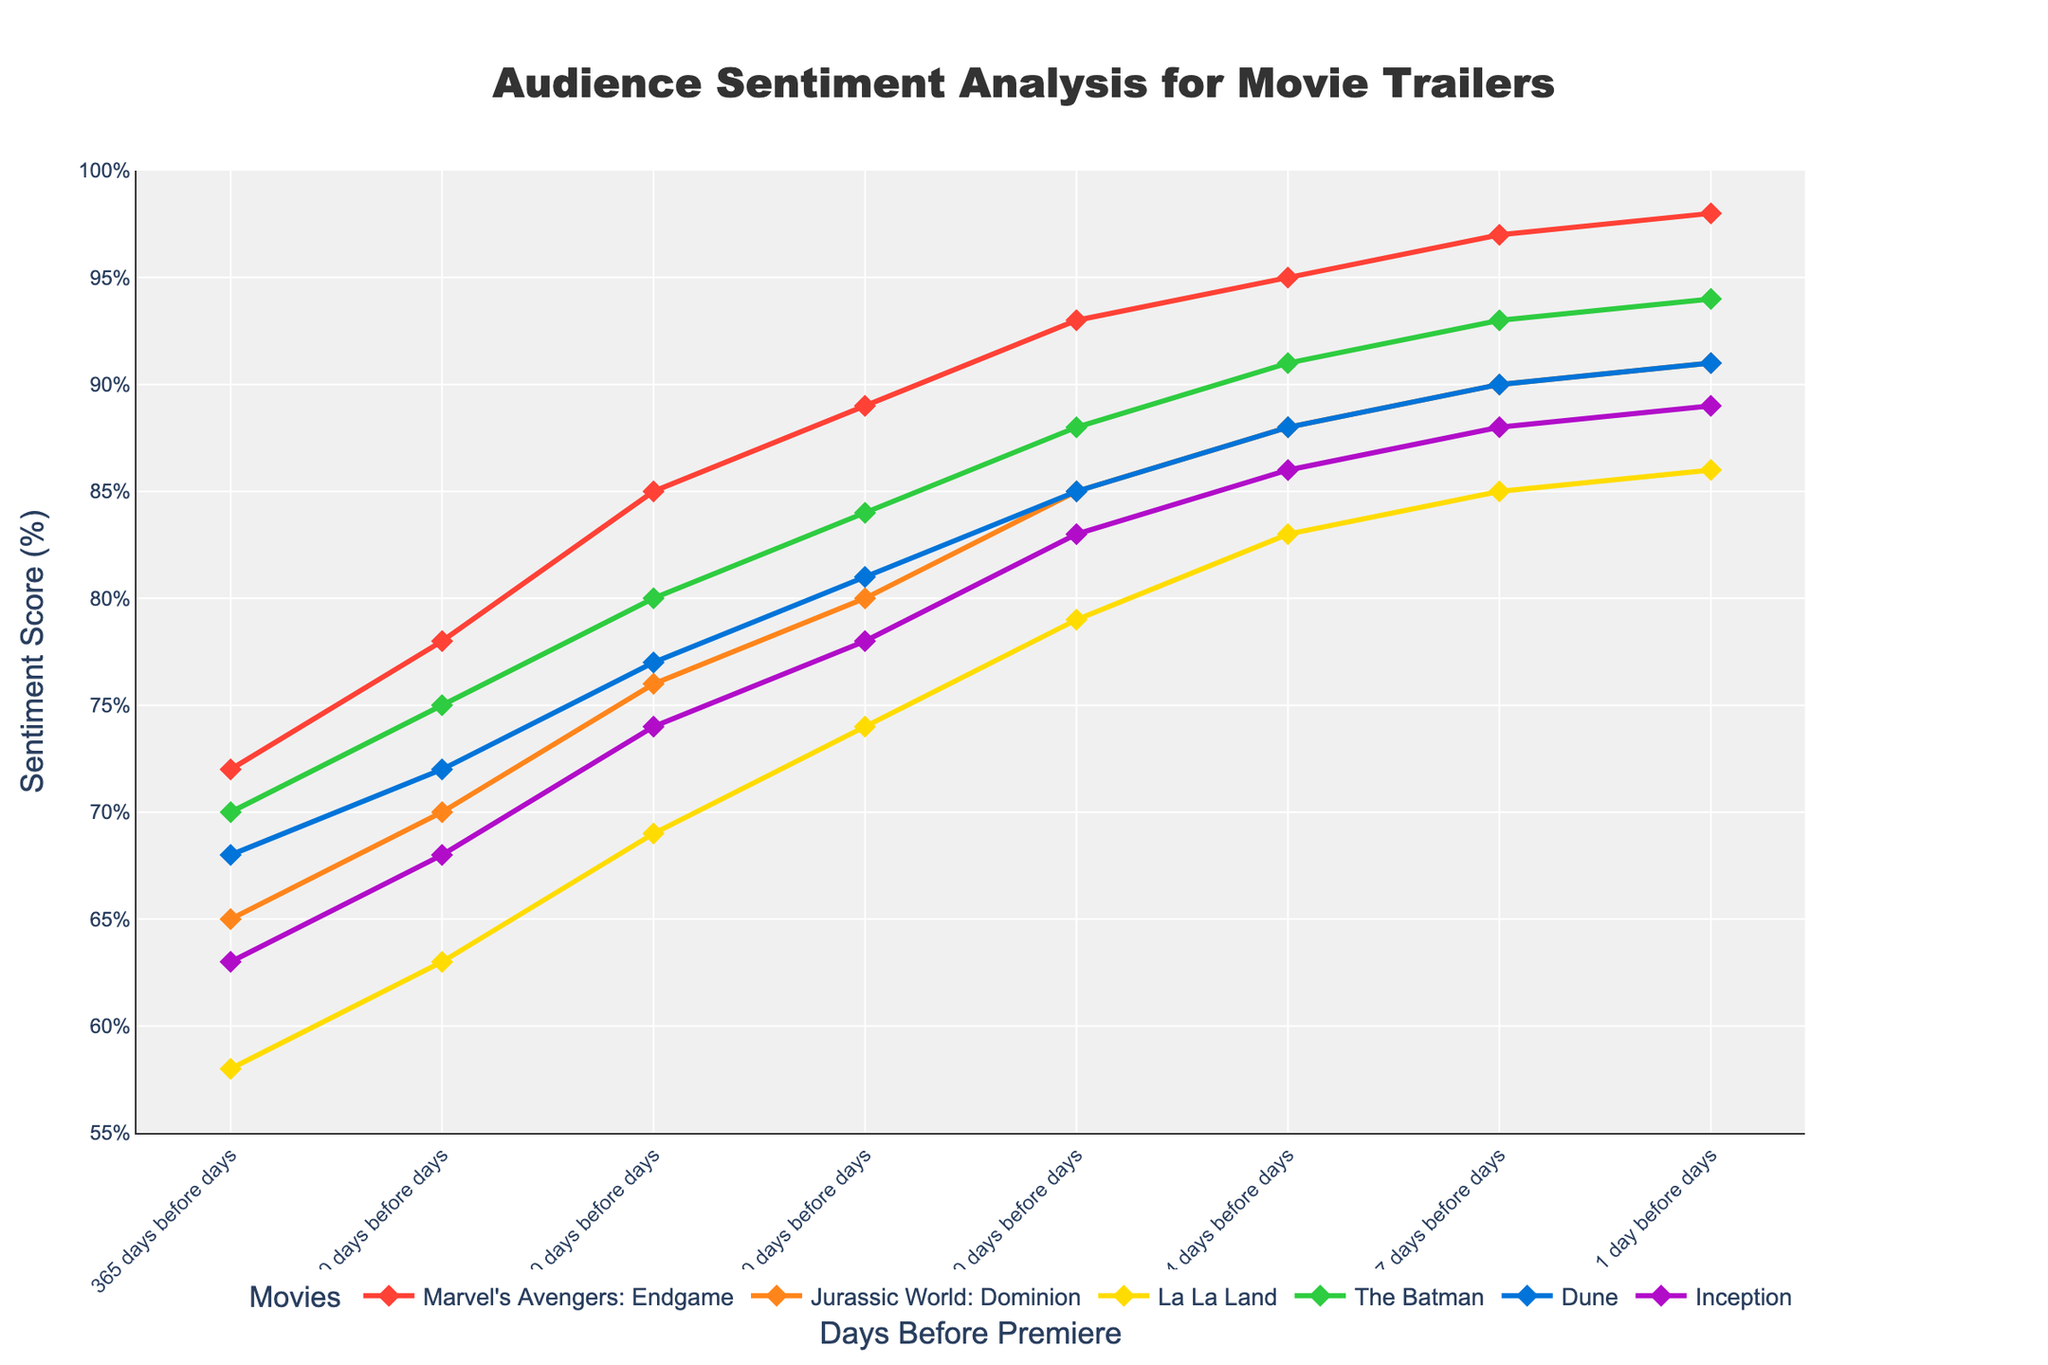What's the sentiment score for "Inception" 60 days before the premiere? Refer to the "Inception" line 60 days before the premiere. The line's point reaches 78%.
Answer: 78% Which movie had the highest sentiment score 30 days before the premiere? Compare the sentiment scores of all movies 30 days before the premiere. "Marvel's Avengers: Endgame" had the highest score at 93%.
Answer: Marvel's Avengers: Endgame Did "La La Land" have a higher sentiment score than "Jurassic World: Dominion" 7 days before the premiere? Check the sentiment scores of both "La La Land" and "Jurassic World: Dominion" 7 days before the premiere. "La La Land" scored 85% while "Jurassic World: Dominion" scored 90%, so "La La Land" had a lower score.
Answer: No On average, how much did the sentiment score for "The Batman" increase between each interval from 365 days to 1 day before the premiere? Calculate the differences for each interval for "The Batman": (75-70), (80-75), (84-80), (88-84), (91-88), (93-91), (94-93), and find the average increase: (5 + 5 + 4 + 4 + 3 + 2 + 1)/7 = 24/7 = 3.43.
Answer: 3.43% Which movie shows the most significant change in sentiment score from 60 days to 30 days before the premiere? Find the change in scores for all movies between 60 and 30 days before the premiere: "Marvel's Avengers: Endgame" (4%), "Jurassic World: Dominion" (5%), "La La Land" (5%), "The Batman" (4%), "Dune" (4%), "Inception" (5%). Multiple movies show a change of 4%, so additional context on significant change could mean others show 5%.
Answer: Jurassic World: Dominion, La La Land, Inception (tie) Which movie had the lowest sentiment score overall, and what is that score? Identify the lowest sentiment score across all intervals and movies. "La La Land" had the lowest score at 58%, 365 days before the premiere.
Answer: La La Land, 58% Was the sentiment score for "Dune" 1 day before the premiere higher or lower than "Inception" 7 days before the premiere? Compare the sentiment score for "Dune" 1 day before (91%) with "Inception" 7 days before (88%). "Dune" had a higher score.
Answer: Higher What is the overall trend in sentiment for "Marvel's Avengers: Endgame" from 365 days to 1 day before the premiere? Observe the increasing sentiment score trend for "Marvel's Avengers: Endgame" from 72% to 98%. The sentiment consistently rises over time.
Answer: Increasing Between which two intervals did "The Batman" see the largest increase in sentiment score? Compare changes in sentiment scores for "The Batman" between each interval. The largest increase (5 points) was between 180 days (70%) and 90 days (75%).
Answer: 180 days to 90 days 